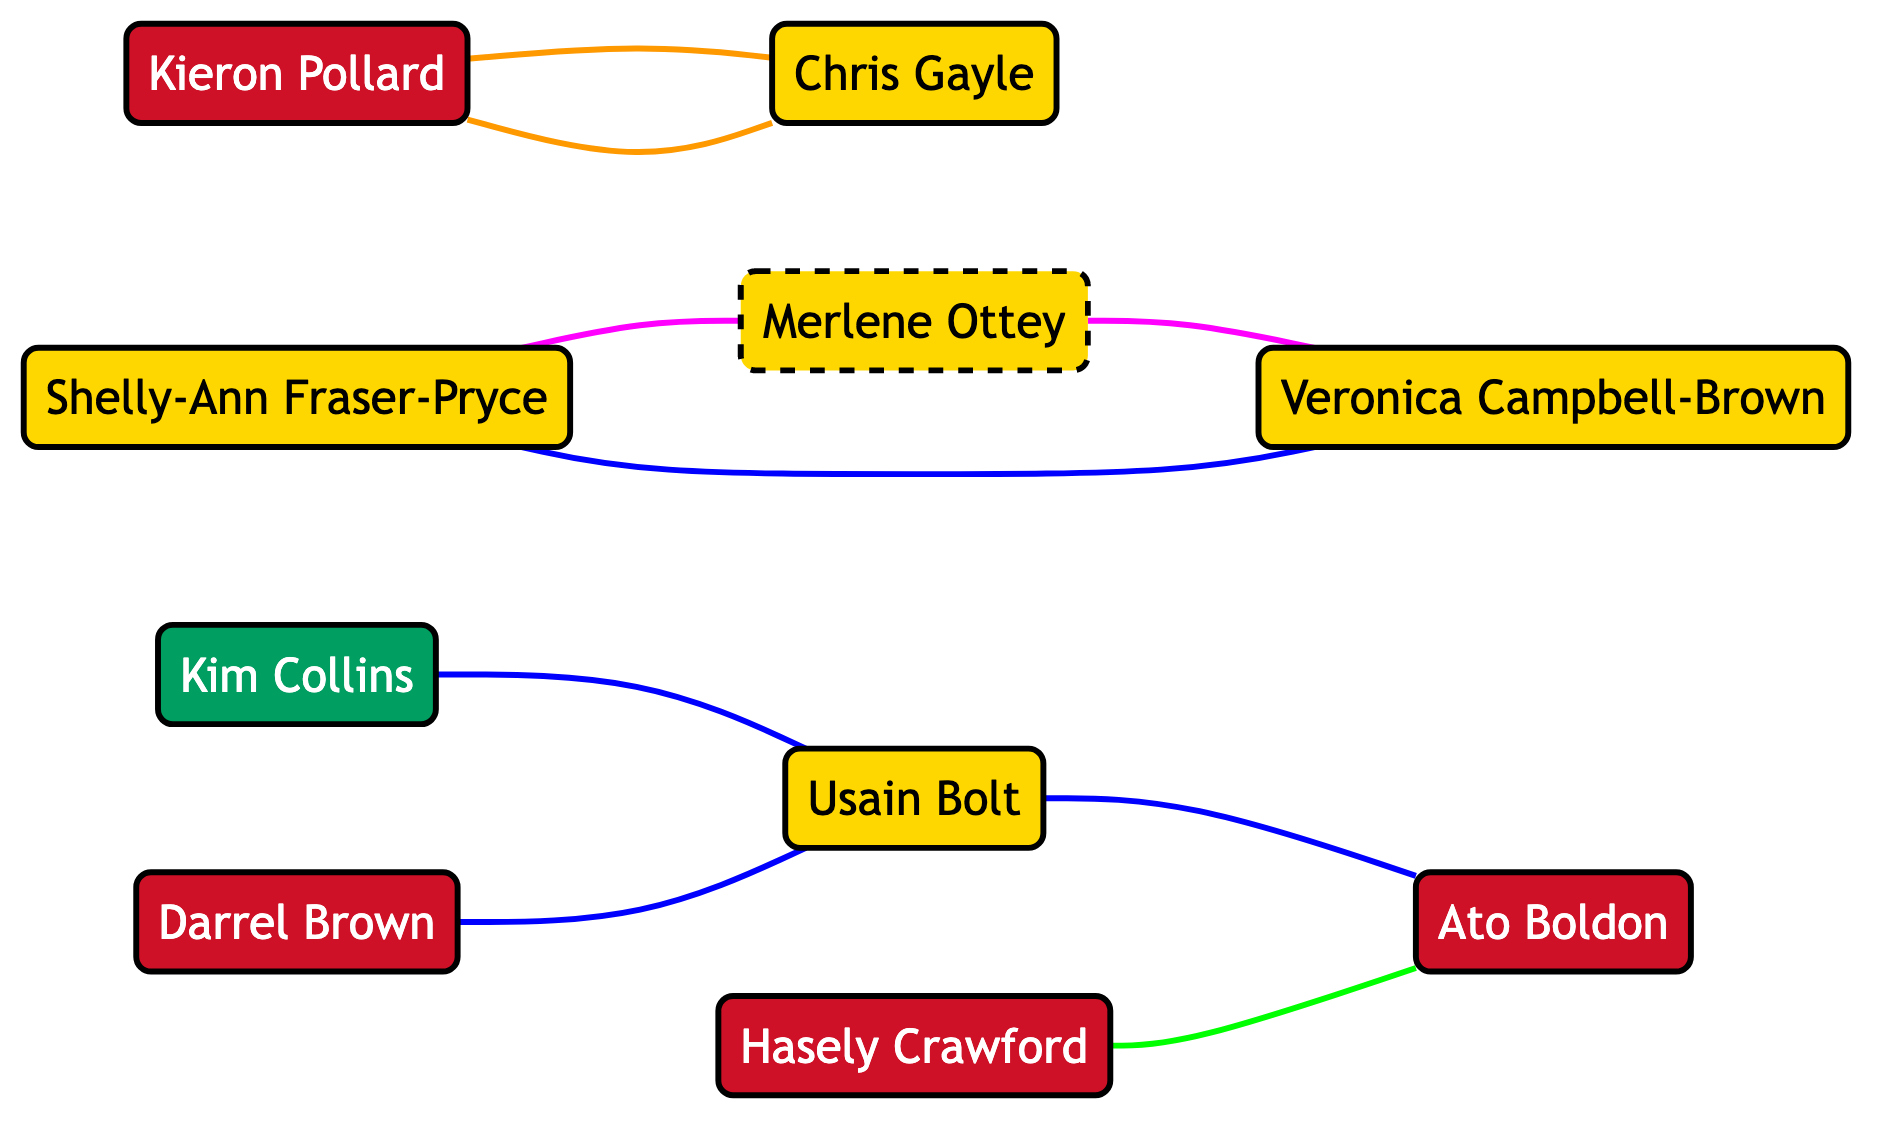What is the total number of athletes represented in the diagram? The diagram has ten unique nodes, and each node represents an athlete. Thus, the total number of athletes is simply the count of these nodes.
Answer: 10 Which two athletes are teammates in the CPL? The diagram shows an edge connecting Kieron Pollard and Chris Gayle labeled "team_mates" in the context of CPL. This relationship clearly identifies them as teammates.
Answer: Kieron Pollard and Chris Gayle How many different countries are represented by the athletes in this diagram? By examining each athlete's country listed in the nodes, we find representatives from Trinidad and Tobago, Jamaica, Saint Kitts and Nevis, and Jamaica/Slovenia. Counting these distinct countries results in four different countries.
Answer: 4 What is the relationship between Usain Bolt and Ato Boldon? The relationship between Usain Bolt and Ato Boldon is marked as "competitors" in the context of the Olympics, which can be seen through the edge connecting these two athletes.
Answer: competitors Who inspired Shelly-Ann Fraser-Pryce in her career? The diagram indicates that Shelly-Ann Fraser-Pryce is inspired by Merlene Ottey as shown in the edge that links these two athletes with the label "inspired_by." This points directly to the source of her inspiration.
Answer: Merlene Ottey Which athlete has a mentorship relationship with Veronica Campbell-Brown? The diagram depicts Merlene Ottey as the mentor to Veronica Campbell-Brown. This is indicated by the edge that connects the two with the "mentorship" label.
Answer: Merlene Ottey How many athletes are competitors with Usain Bolt? Analyzing the edges, we see that Usain Bolt has three competitors: Ato Boldon, Kim Collins, and Darrel Brown. This is determined by counting all edges connecting to Usain Bolt with the "competitors" label.
Answer: 3 Which athlete is identified as an inspiration to Ato Boldon? The relationship labeled "inspiration" connects Hasely Crawford to Ato Boldon, as shown in the diagram. This explicitly states that Hasely Crawford serves as an inspiration for Ato Boldon.
Answer: Hasely Crawford Is there a connection between Kim Collins and Usain Bolt? Yes, they are connected as "competitors" in the context of the World Championships, as indicated by the edge between these two athletes in the diagram.
Answer: Yes 